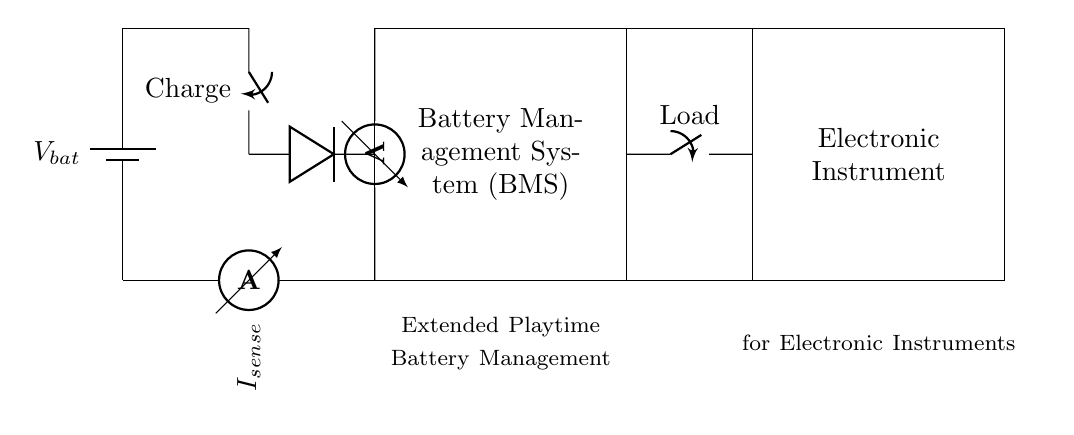What is the main function of the battery management system? The main function of the battery management system is to manage the charging and discharging of the battery, ensuring safe operation and optimal performance.
Answer: to manage battery What component is used to sense current in the circuit? The ammeter is used to sense the current flowing through the circuit, allowing for monitoring the battery discharge and performance.
Answer: ammeter What is the purpose of the diode in the circuit? The diode's purpose is to allow current to flow in one direction during the charging process while preventing backflow from the electronic instrument to the battery.
Answer: to prevent backflow What happens when the load switch is open? When the load switch is open, the electronic instrument is disconnected from the battery, effectively stopping the current flow to the instrument.
Answer: stops current flow How is voltage measured in this circuit? Voltage is measured using a voltmeter which is connected across the battery terminals to determine the potential difference available at that point.
Answer: voltmeter What does the extended playtime battery management aim for? The extended playtime battery management aims to maximize the battery lifespan and ensure more prolonged use of electronic instruments without frequent recharging.
Answer: maximize lifespan What type of circuit is represented here? This circuit represents a battery management system designed for portable electronic instruments requiring efficient power management.
Answer: battery management system 